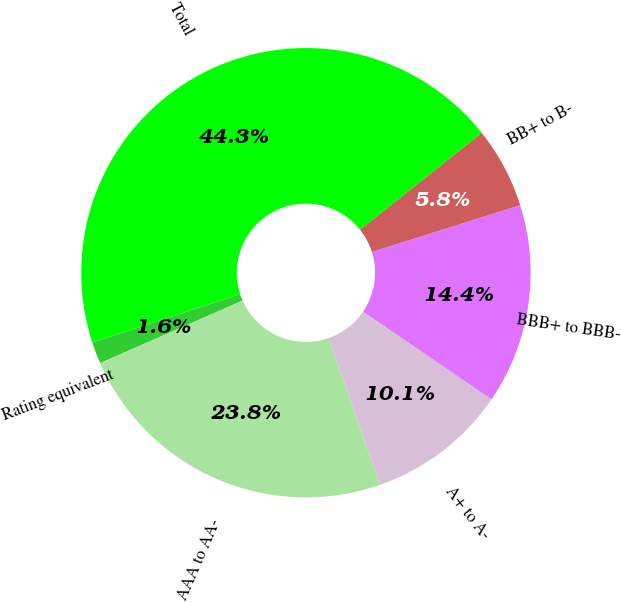Convert chart to OTSL. <chart><loc_0><loc_0><loc_500><loc_500><pie_chart><fcel>Rating equivalent<fcel>AAA to AA-<fcel>A+ to A-<fcel>BBB+ to BBB-<fcel>BB+ to B-<fcel>Total<nl><fcel>1.57%<fcel>23.76%<fcel>10.12%<fcel>14.39%<fcel>5.84%<fcel>44.32%<nl></chart> 